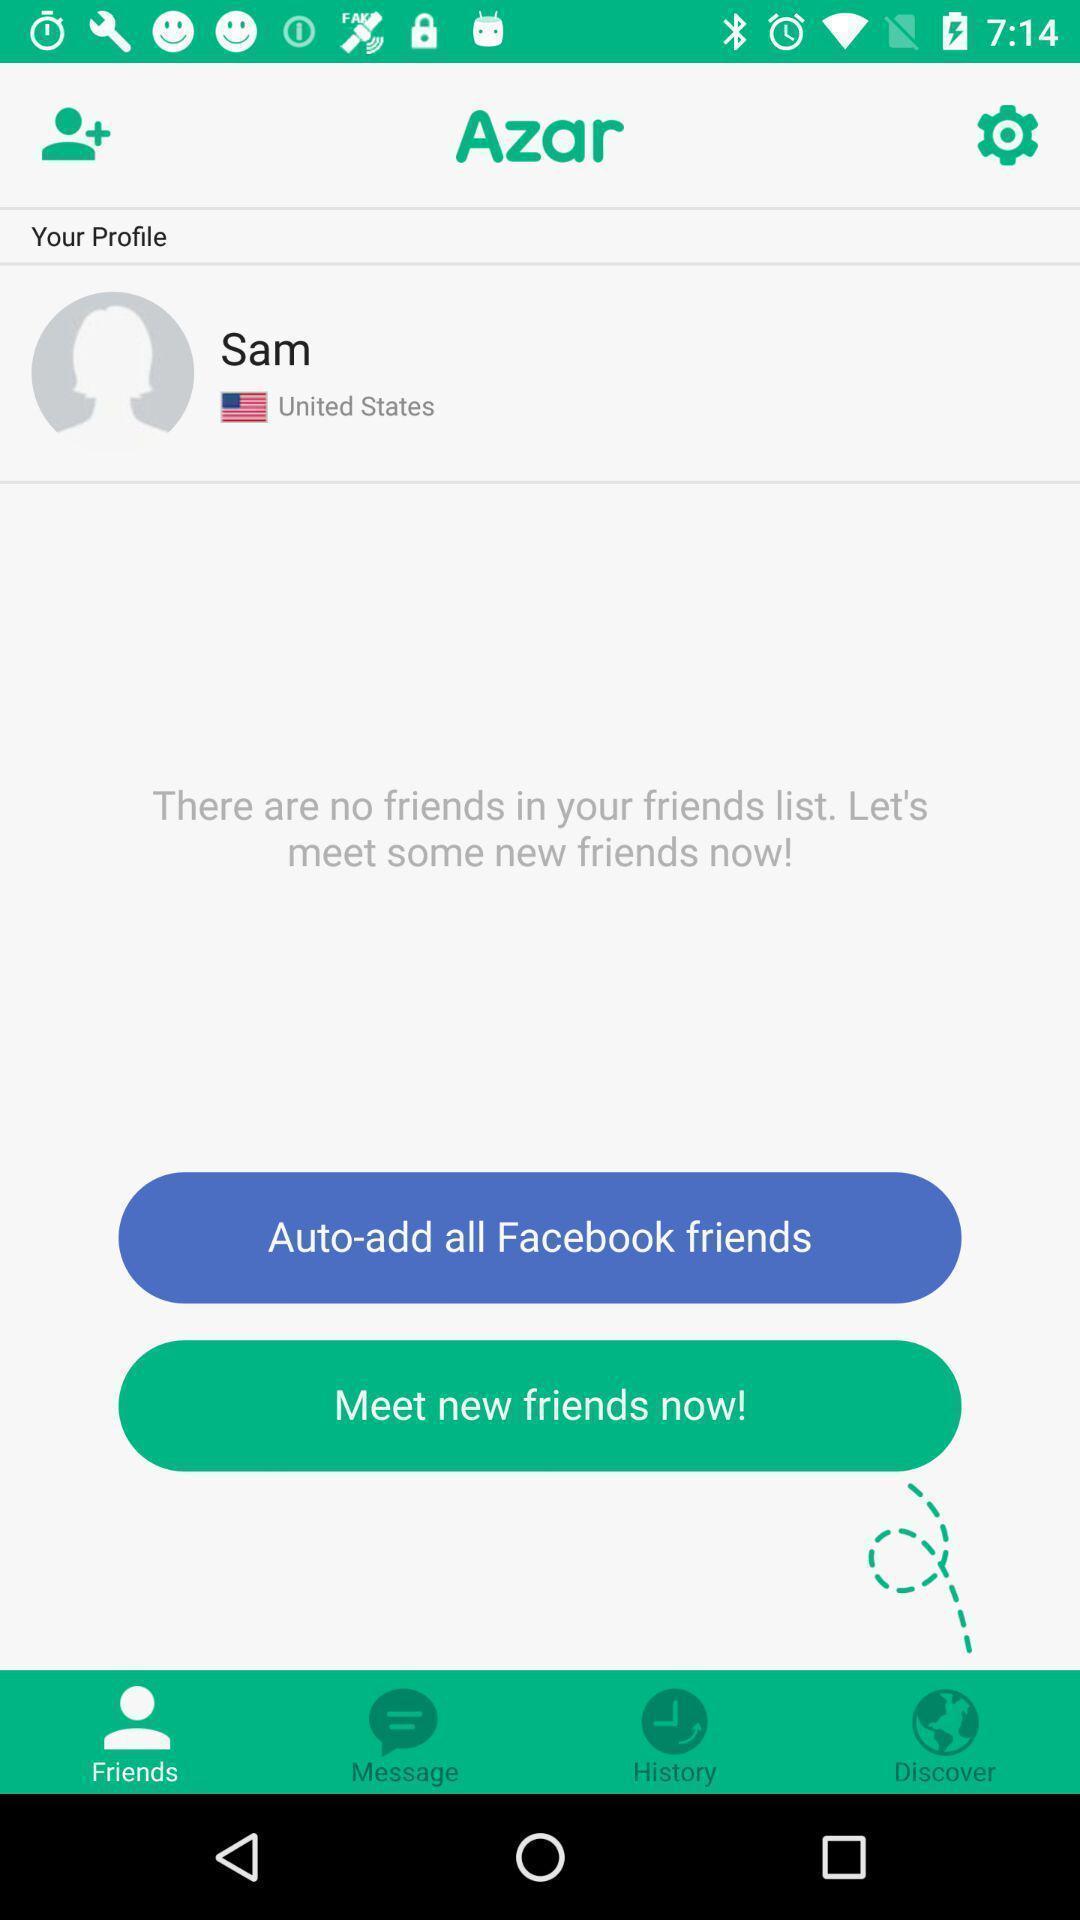What can you discern from this picture? Screen displaying user information and other options. 